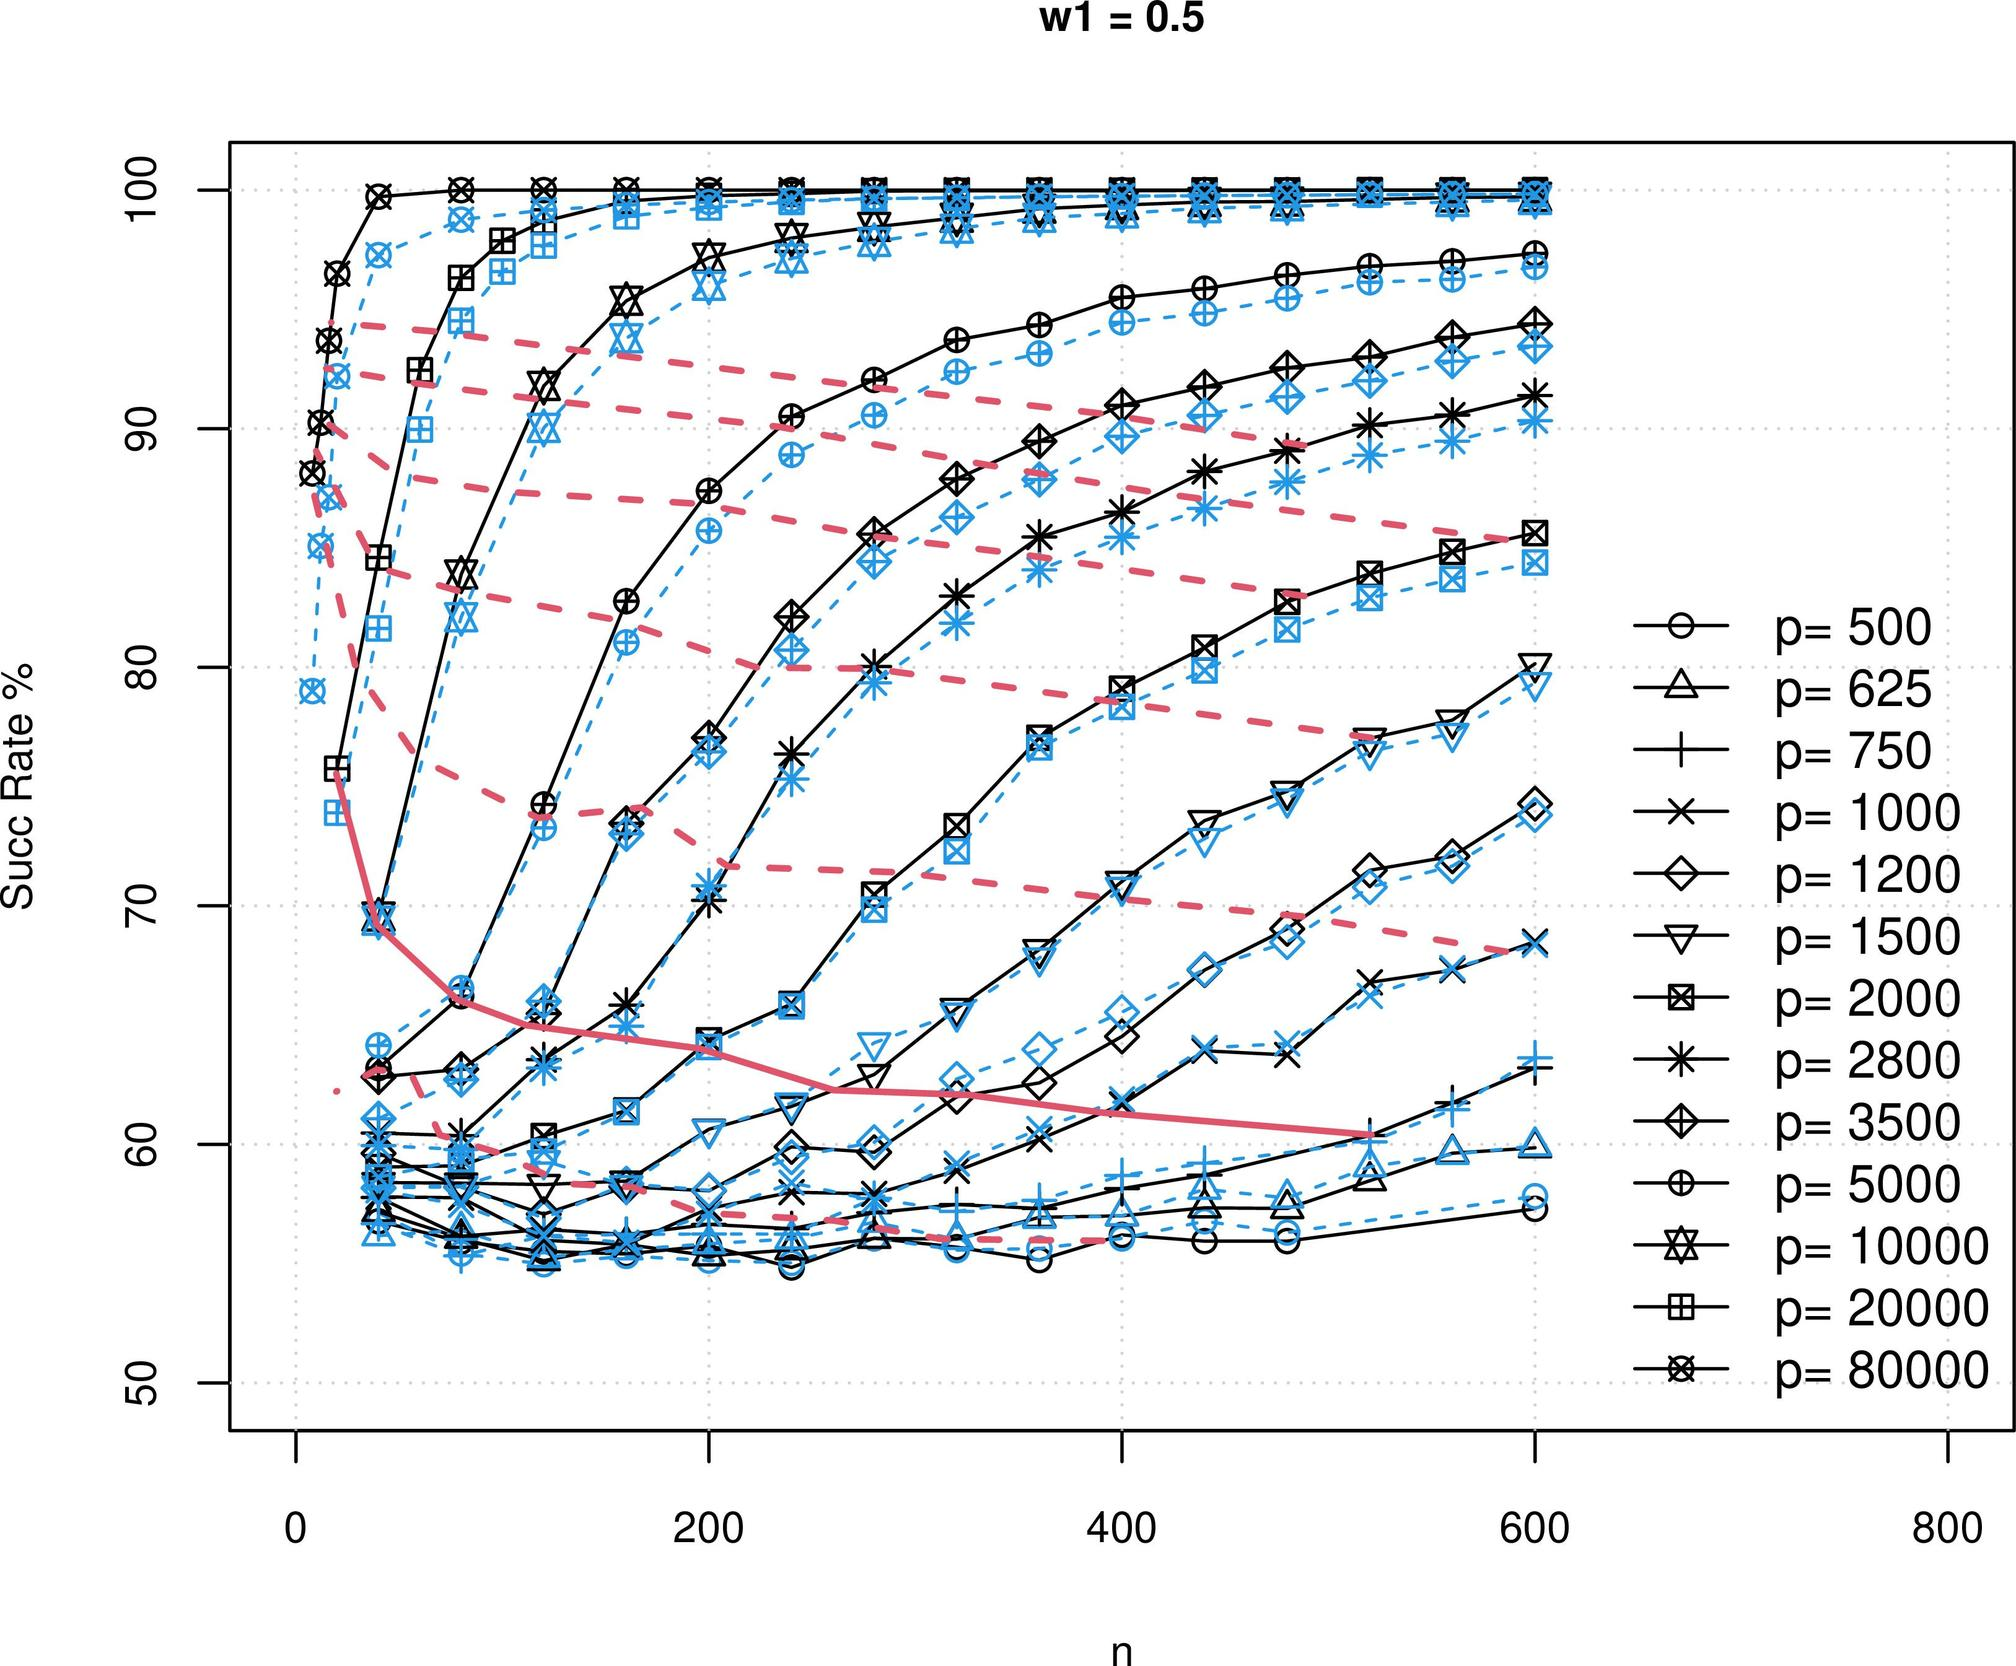How do different 'p' values influence the success rate for a given 'n'? The graph shows varying 'p' values represented by different symbols. For any specific value of 'n', increasing 'p' typically corresponds to a higher success rate. Different lines run parallel or close to parallel, with higher 'p' values starting at higher success rates at n=0 and maintaining this advantage as 'n' increases. 